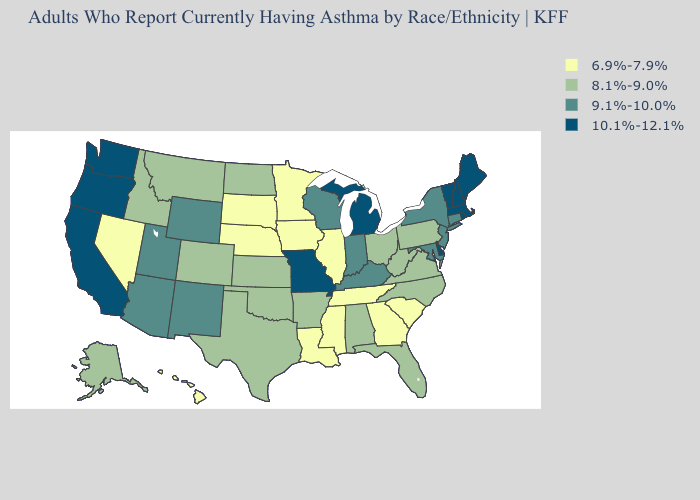What is the value of California?
Keep it brief. 10.1%-12.1%. What is the lowest value in the South?
Short answer required. 6.9%-7.9%. Is the legend a continuous bar?
Short answer required. No. Among the states that border Maine , which have the lowest value?
Keep it brief. New Hampshire. Name the states that have a value in the range 6.9%-7.9%?
Be succinct. Georgia, Hawaii, Illinois, Iowa, Louisiana, Minnesota, Mississippi, Nebraska, Nevada, South Carolina, South Dakota, Tennessee. What is the lowest value in the South?
Be succinct. 6.9%-7.9%. What is the value of Arizona?
Short answer required. 9.1%-10.0%. Name the states that have a value in the range 9.1%-10.0%?
Keep it brief. Arizona, Connecticut, Indiana, Kentucky, Maryland, New Jersey, New Mexico, New York, Utah, Wisconsin, Wyoming. Name the states that have a value in the range 6.9%-7.9%?
Quick response, please. Georgia, Hawaii, Illinois, Iowa, Louisiana, Minnesota, Mississippi, Nebraska, Nevada, South Carolina, South Dakota, Tennessee. Name the states that have a value in the range 6.9%-7.9%?
Quick response, please. Georgia, Hawaii, Illinois, Iowa, Louisiana, Minnesota, Mississippi, Nebraska, Nevada, South Carolina, South Dakota, Tennessee. Name the states that have a value in the range 6.9%-7.9%?
Give a very brief answer. Georgia, Hawaii, Illinois, Iowa, Louisiana, Minnesota, Mississippi, Nebraska, Nevada, South Carolina, South Dakota, Tennessee. Is the legend a continuous bar?
Give a very brief answer. No. Name the states that have a value in the range 9.1%-10.0%?
Give a very brief answer. Arizona, Connecticut, Indiana, Kentucky, Maryland, New Jersey, New Mexico, New York, Utah, Wisconsin, Wyoming. Among the states that border Indiana , does Illinois have the lowest value?
Be succinct. Yes. What is the value of Oklahoma?
Quick response, please. 8.1%-9.0%. 